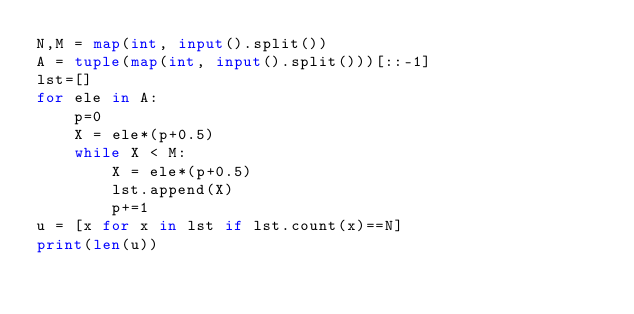Convert code to text. <code><loc_0><loc_0><loc_500><loc_500><_Python_>N,M = map(int, input().split())
A = tuple(map(int, input().split()))[::-1]
lst=[]
for ele in A:
    p=0
    X = ele*(p+0.5)
    while X < M:
        X = ele*(p+0.5)
        lst.append(X)
        p+=1
u = [x for x in lst if lst.count(x)==N]
print(len(u))</code> 